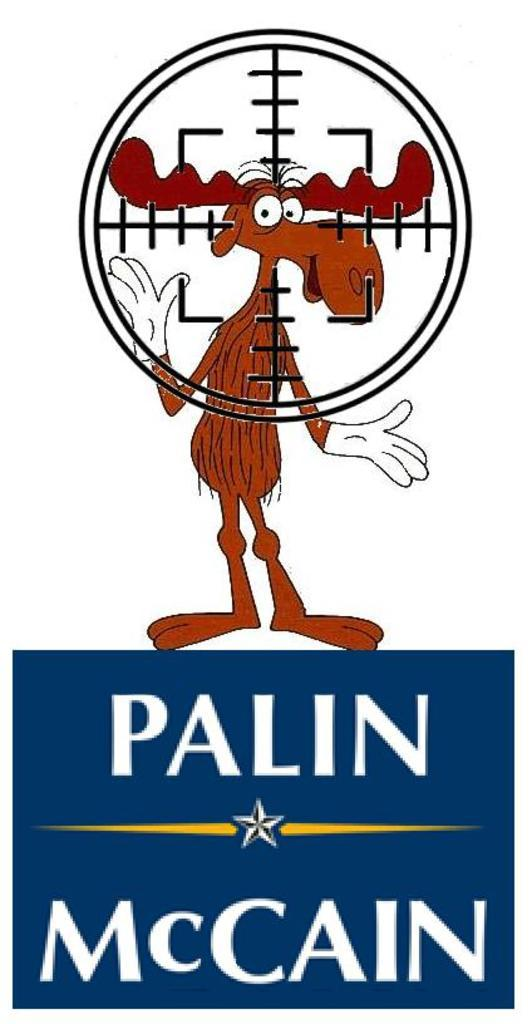<image>
Present a compact description of the photo's key features. An image of Bullwinkle in crosshairs standing on a blue "Palin McCain" logo. 